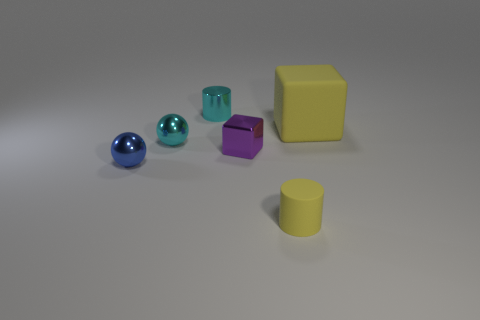What is the shape of the large matte thing that is the same color as the tiny matte thing?
Give a very brief answer. Cube. How big is the yellow rubber thing behind the shiny block?
Your answer should be compact. Large. The block that is the same size as the shiny cylinder is what color?
Offer a very short reply. Purple. Are there any small cylinders that have the same color as the large rubber cube?
Make the answer very short. Yes. Are there fewer cyan metallic balls in front of the small metallic cube than small cyan things on the right side of the yellow cylinder?
Give a very brief answer. No. There is a thing that is both right of the small purple cube and behind the tiny blue sphere; what material is it?
Offer a terse response. Rubber. Does the large yellow rubber object have the same shape as the rubber object that is in front of the small purple shiny thing?
Give a very brief answer. No. What number of other objects are the same size as the yellow cylinder?
Provide a succinct answer. 4. Are there more yellow cubes than large red blocks?
Your answer should be compact. Yes. How many objects are on the right side of the small purple metallic block and on the left side of the large yellow cube?
Your answer should be very brief. 1. 